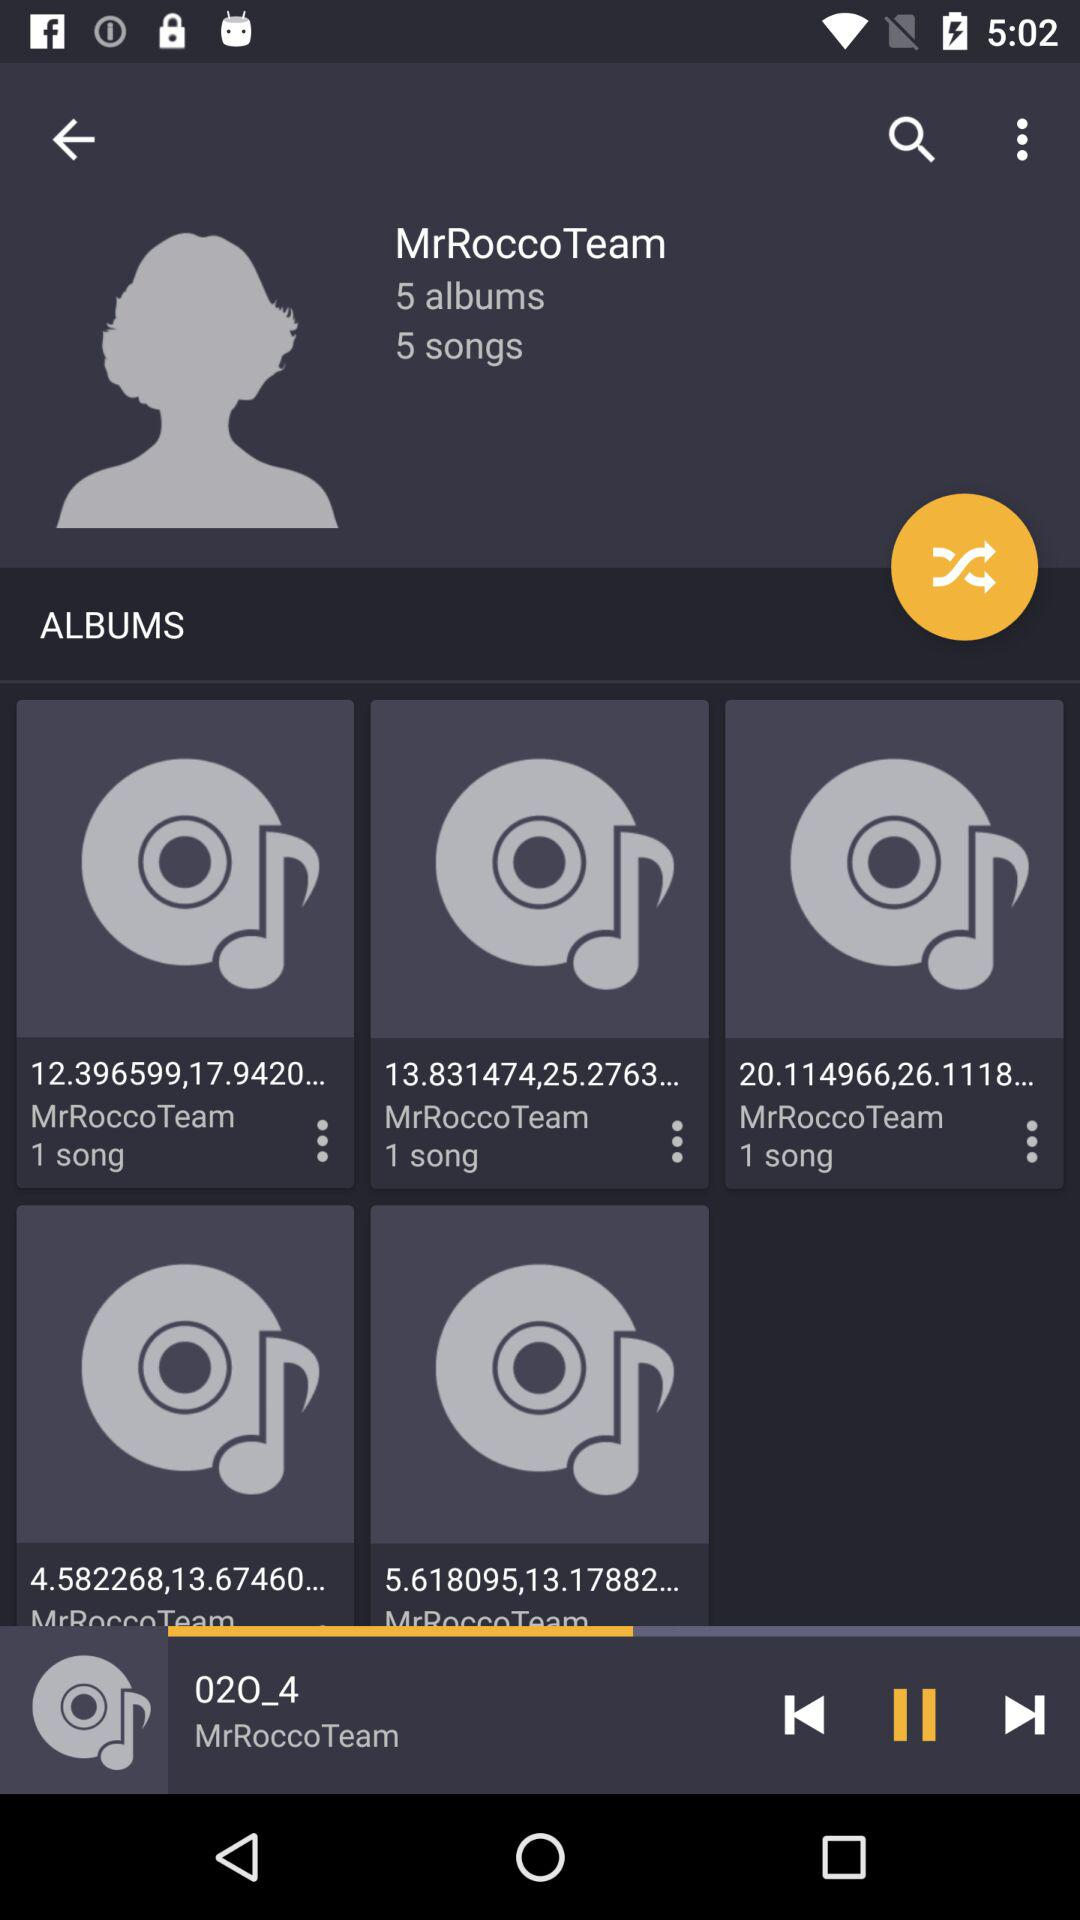How many songs are there? There are 5 songs. 